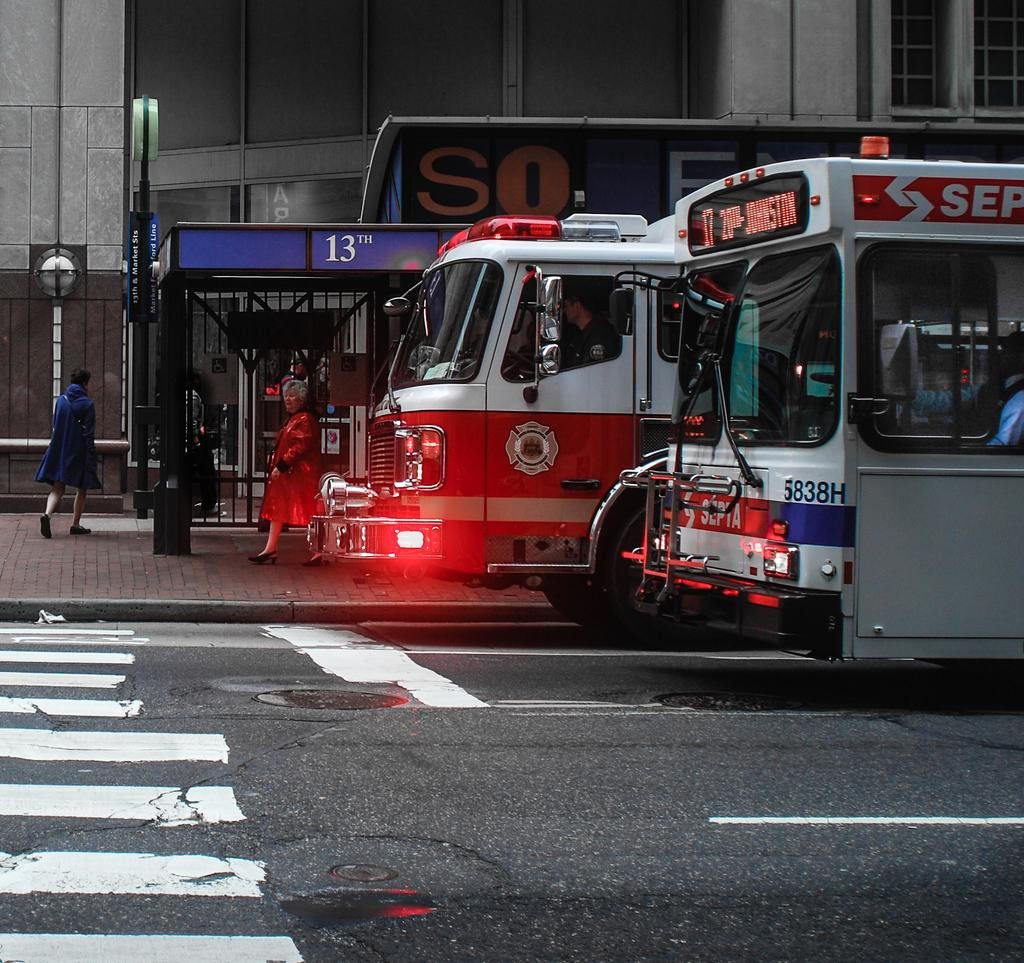What types of vehicles can be seen in the image? There are vehicles in the image, but the specific types are not mentioned. What kind of transportation infrastructure is present in the image? There is a road and a bus stop in the image. What other pathways are visible in the image? There is a path in the image. What structures are present in the image that support signage or advertisements? There are poles in the image with posters that have text. Who or what is present in the image? There are people in the image. What type of building is visible in the image? There is a building with windows in the image. What architectural feature is present that allows access to the building? There is a door in the image. What scientific discoveries are being discussed at the bus stop in the image? There is no indication in the image that scientific discoveries are being discussed at the bus stop. How does the way people walk in the image relate to the vehicles present? The image does not show how people walk, and there is no direct relationship between the way people walk and the vehicles present. 